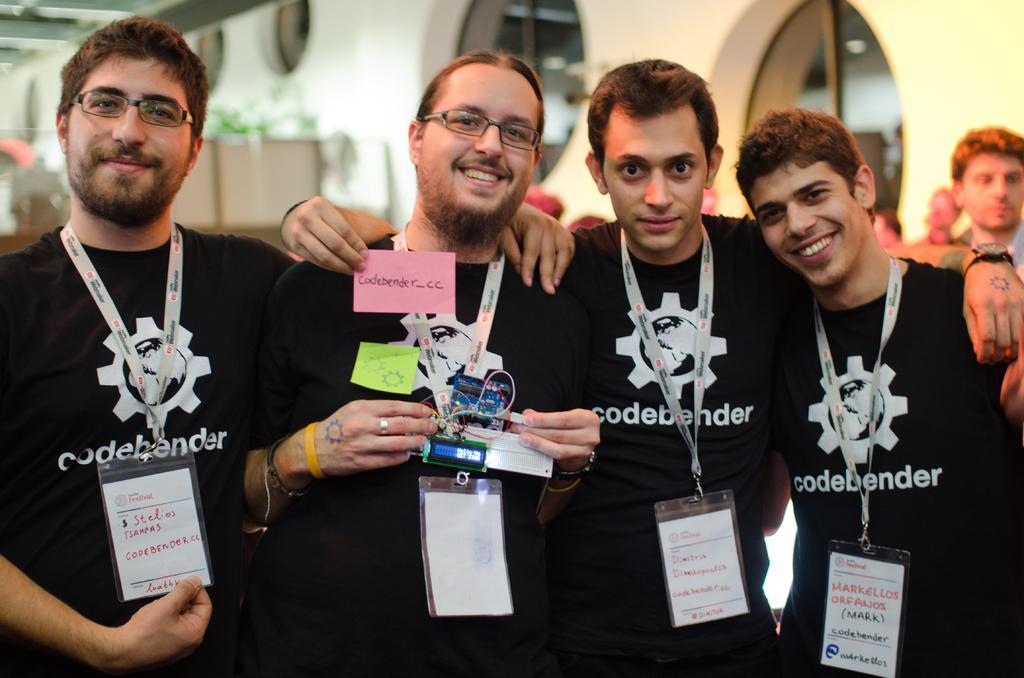Could you give a brief overview of what you see in this image? In this image there are four people standing with a smile on their face and there are like ID cards with some text on it are hanging on their neck, one of them is holding something in his hand and the other one is holding a paper with some text. Behind them there are few people and a wall, there are a few objects which are not clear. 